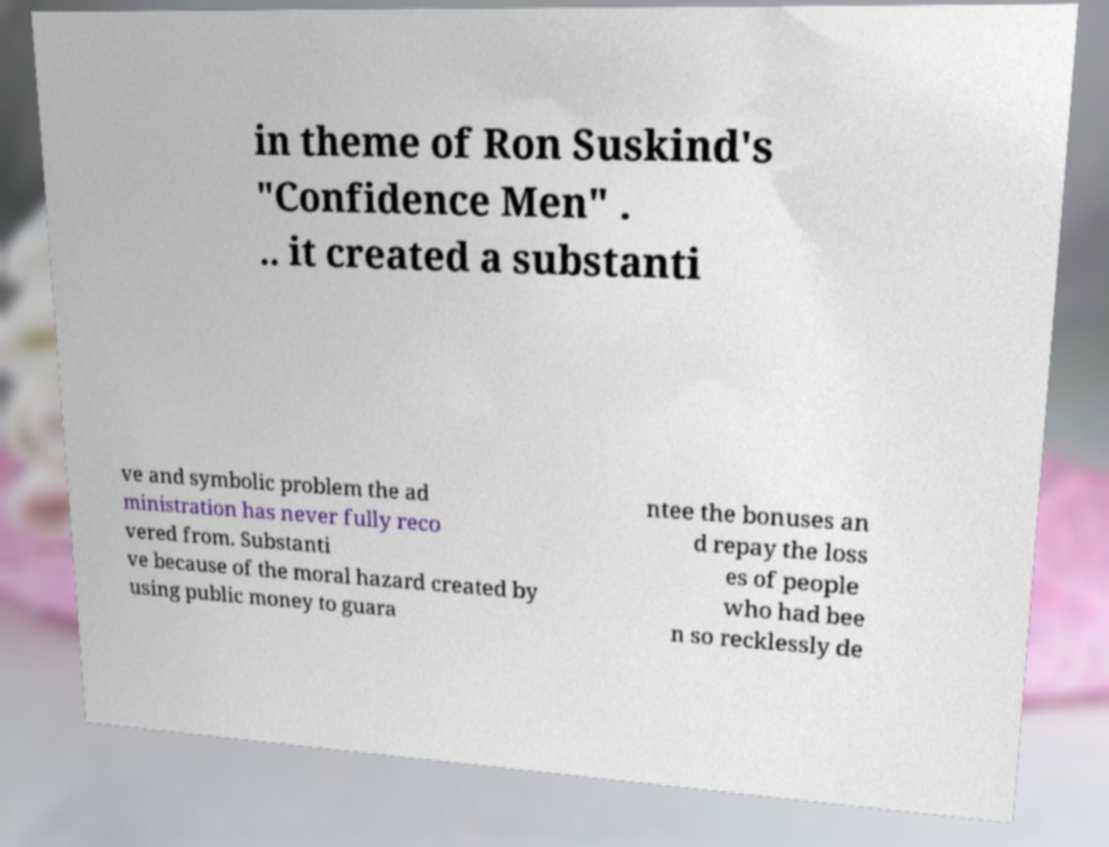Please read and relay the text visible in this image. What does it say? in theme of Ron Suskind's "Confidence Men" . .. it created a substanti ve and symbolic problem the ad ministration has never fully reco vered from. Substanti ve because of the moral hazard created by using public money to guara ntee the bonuses an d repay the loss es of people who had bee n so recklessly de 